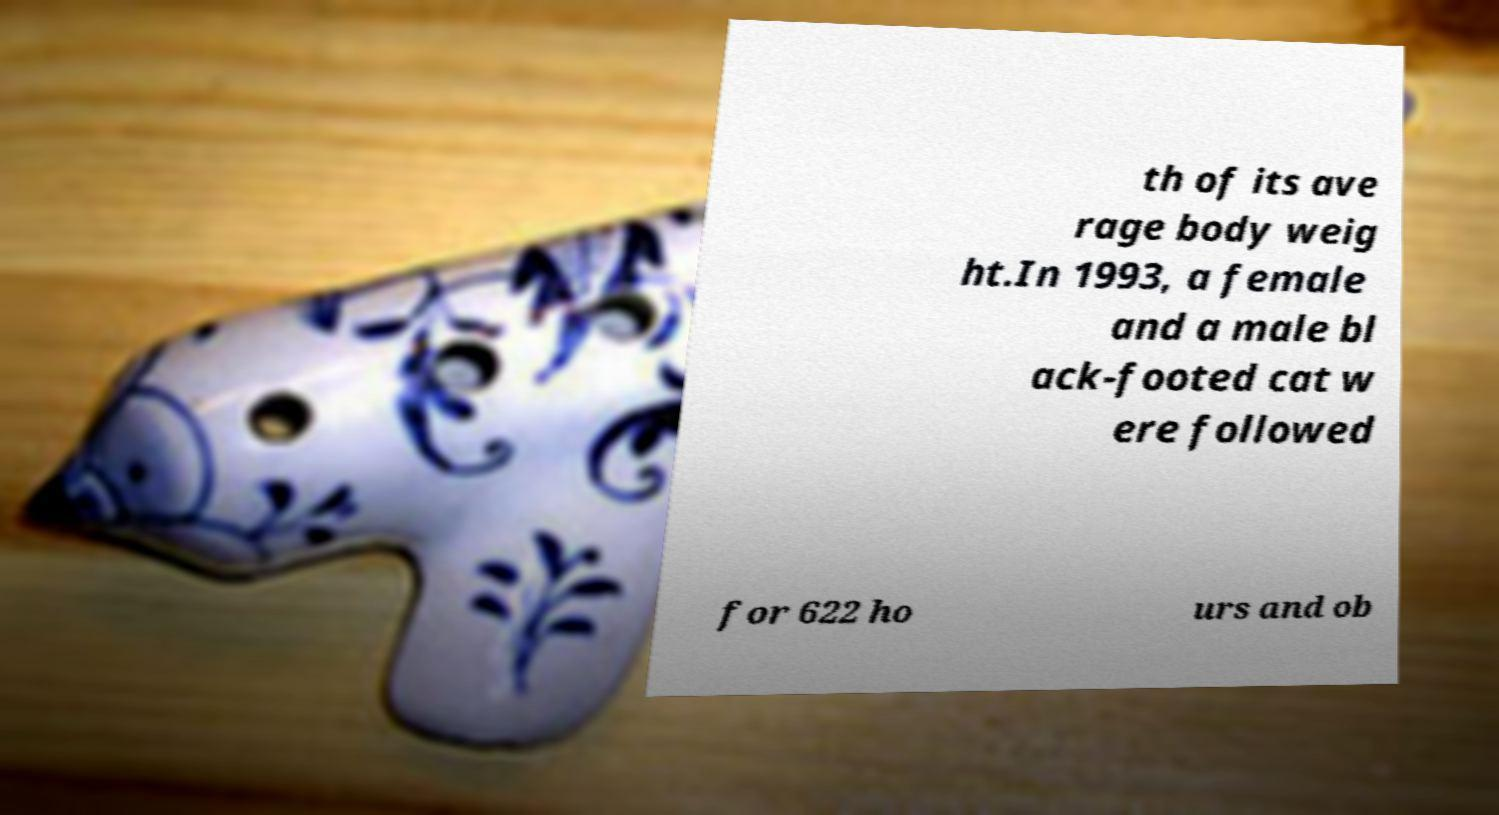Could you extract and type out the text from this image? th of its ave rage body weig ht.In 1993, a female and a male bl ack-footed cat w ere followed for 622 ho urs and ob 